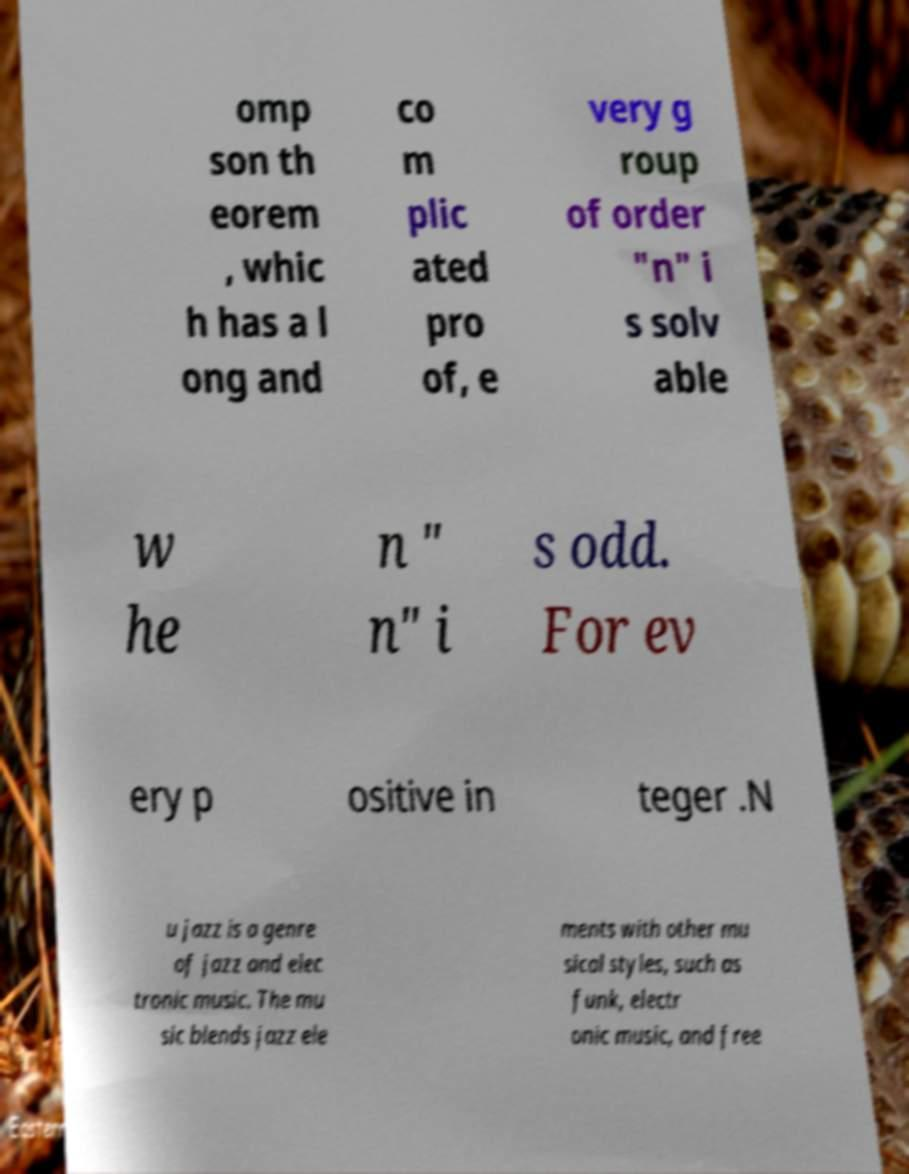Please identify and transcribe the text found in this image. omp son th eorem , whic h has a l ong and co m plic ated pro of, e very g roup of order "n" i s solv able w he n " n" i s odd. For ev ery p ositive in teger .N u jazz is a genre of jazz and elec tronic music. The mu sic blends jazz ele ments with other mu sical styles, such as funk, electr onic music, and free 